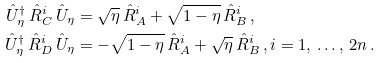<formula> <loc_0><loc_0><loc_500><loc_500>\hat { U } _ { \eta } ^ { \dag } \, \hat { R } _ { C } ^ { i } \, \hat { U } _ { \eta } & = \sqrt { \eta } \, \hat { R } _ { A } ^ { i } + \sqrt { 1 - \eta } \, \hat { R } _ { B } ^ { i } \, , \\ \hat { U } _ { \eta } ^ { \dag } \, \hat { R } _ { D } ^ { i } \, \hat { U } _ { \eta } & = - \sqrt { 1 - \eta } \, \hat { R } _ { A } ^ { i } + \sqrt { \eta } \, \hat { R } _ { B } ^ { i } \, , i = 1 , \, \dots , \, 2 n \, .</formula> 